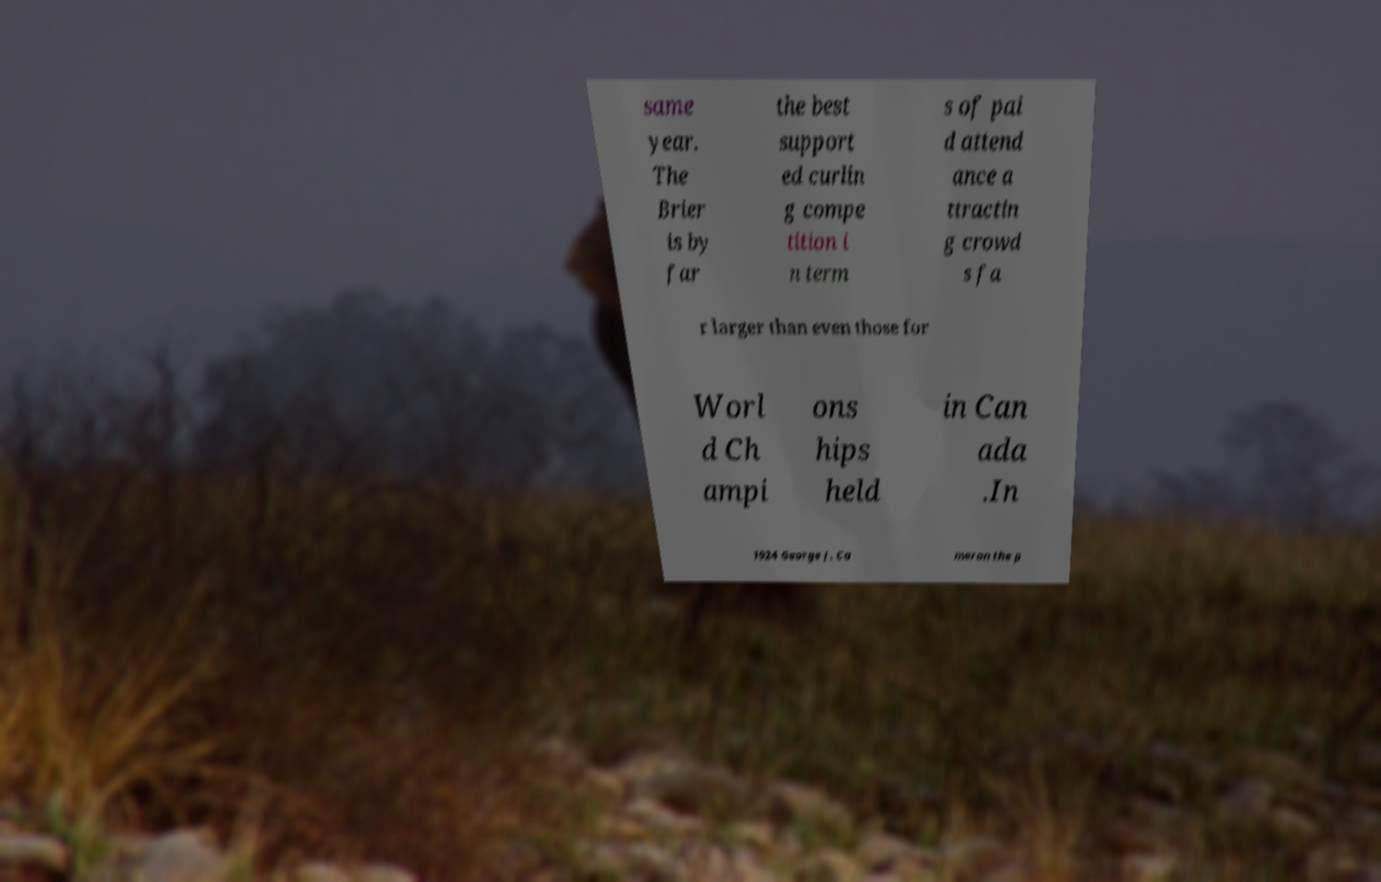Please identify and transcribe the text found in this image. same year. The Brier is by far the best support ed curlin g compe tition i n term s of pai d attend ance a ttractin g crowd s fa r larger than even those for Worl d Ch ampi ons hips held in Can ada .In 1924 George J. Ca meron the p 